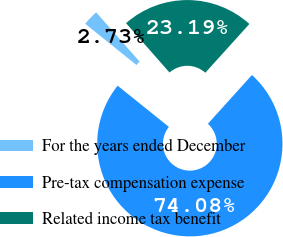<chart> <loc_0><loc_0><loc_500><loc_500><pie_chart><fcel>For the years ended December<fcel>Pre-tax compensation expense<fcel>Related income tax benefit<nl><fcel>2.73%<fcel>74.08%<fcel>23.19%<nl></chart> 